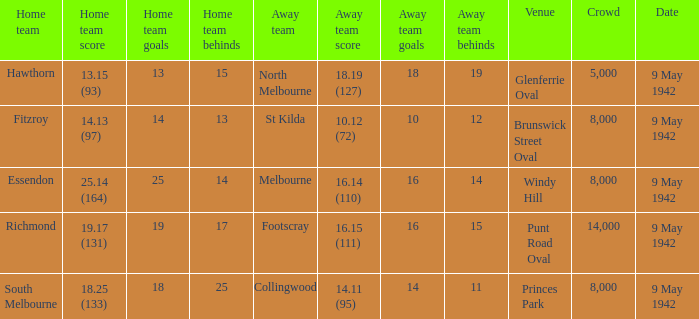How many people attended the game with the home team scoring 18.25 (133)? 1.0. 